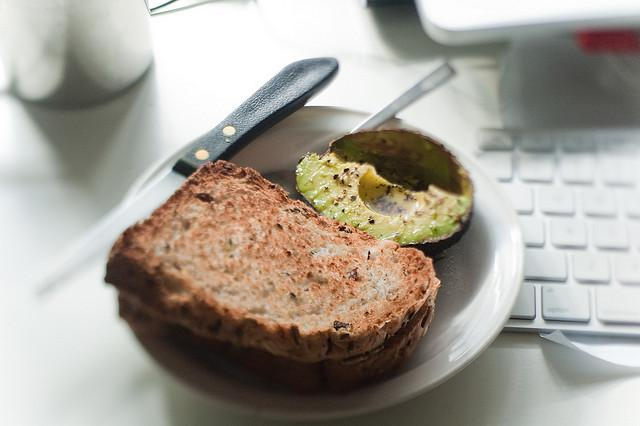What is going on the toast? Please explain your reasoning. avocado. We can presume that the avocado slice will be spread onto the bread with the nearby knife. 